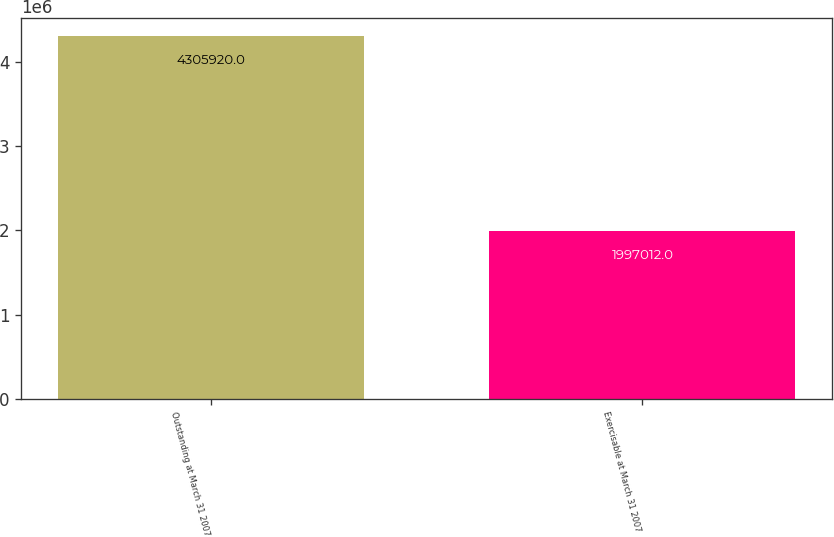<chart> <loc_0><loc_0><loc_500><loc_500><bar_chart><fcel>Outstanding at March 31 2007<fcel>Exercisable at March 31 2007<nl><fcel>4.30592e+06<fcel>1.99701e+06<nl></chart> 